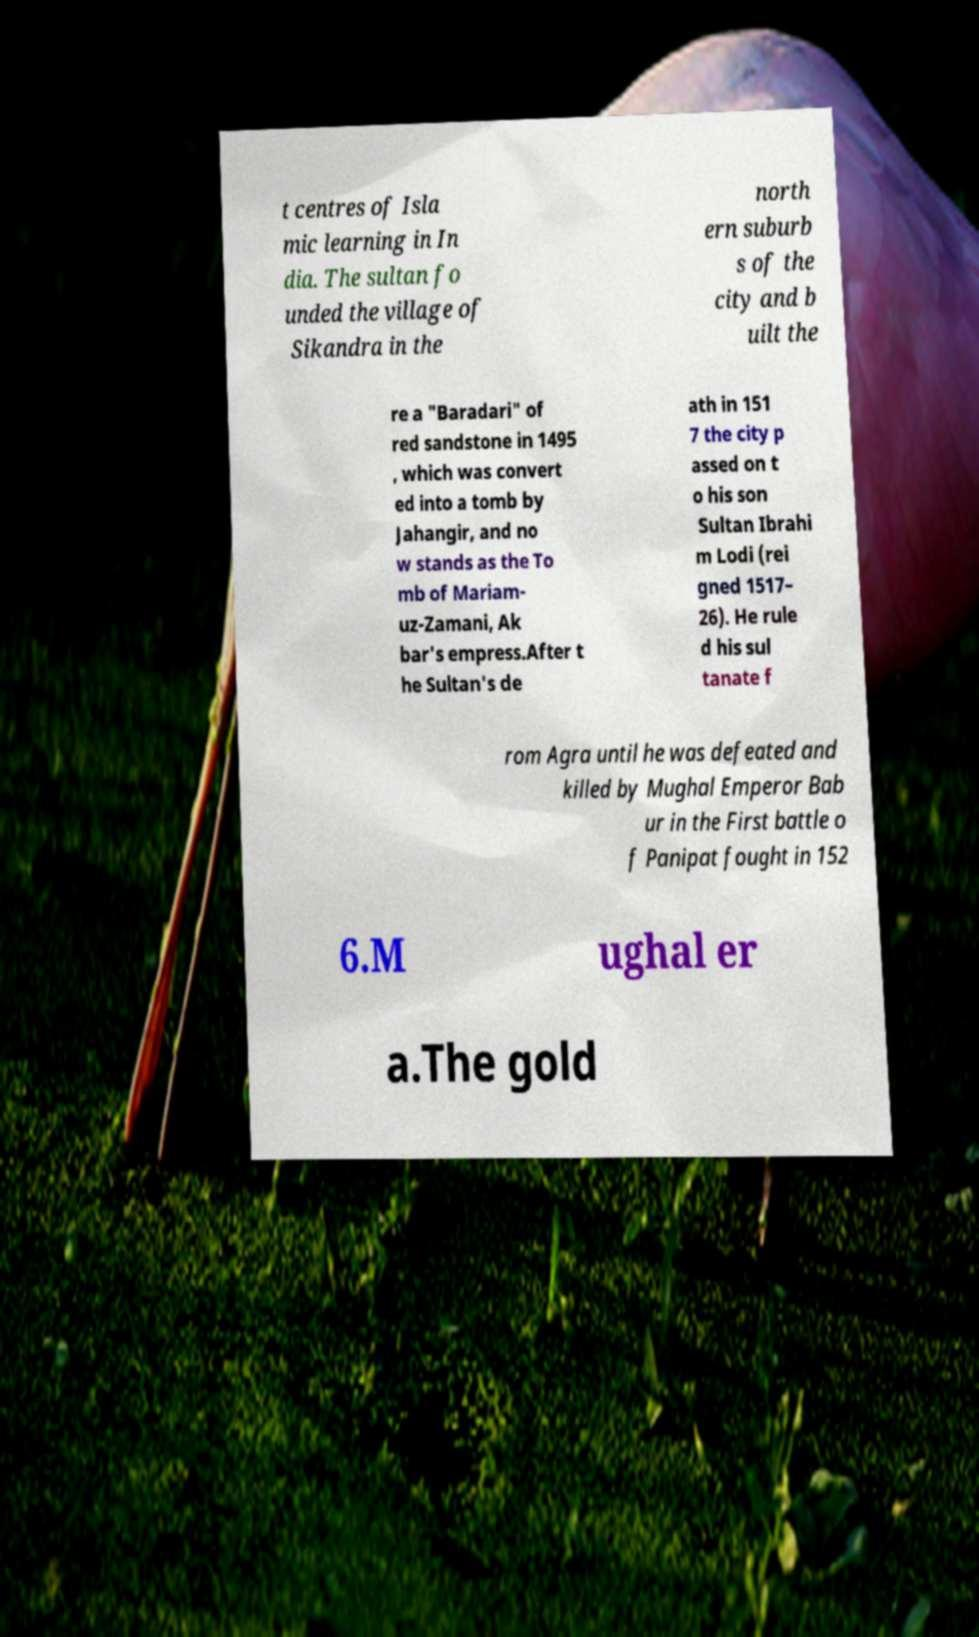Could you extract and type out the text from this image? t centres of Isla mic learning in In dia. The sultan fo unded the village of Sikandra in the north ern suburb s of the city and b uilt the re a "Baradari" of red sandstone in 1495 , which was convert ed into a tomb by Jahangir, and no w stands as the To mb of Mariam- uz-Zamani, Ak bar's empress.After t he Sultan's de ath in 151 7 the city p assed on t o his son Sultan Ibrahi m Lodi (rei gned 1517– 26). He rule d his sul tanate f rom Agra until he was defeated and killed by Mughal Emperor Bab ur in the First battle o f Panipat fought in 152 6.M ughal er a.The gold 